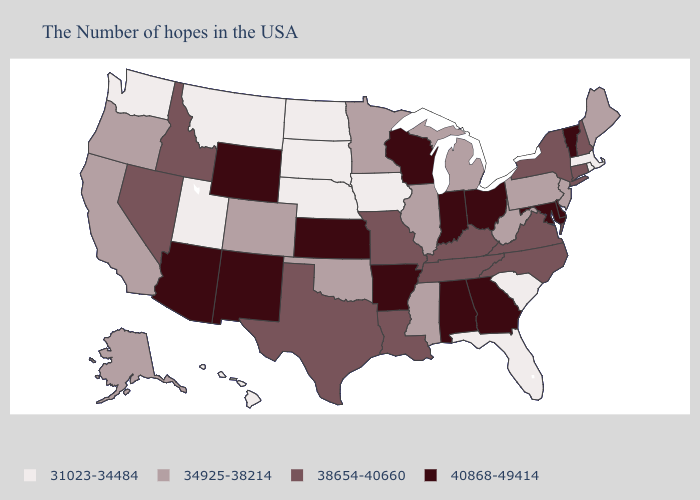Which states have the lowest value in the West?
Write a very short answer. Utah, Montana, Washington, Hawaii. Does Arizona have the same value as Illinois?
Write a very short answer. No. Among the states that border Nevada , does Utah have the highest value?
Be succinct. No. Name the states that have a value in the range 34925-38214?
Be succinct. Maine, New Jersey, Pennsylvania, West Virginia, Michigan, Illinois, Mississippi, Minnesota, Oklahoma, Colorado, California, Oregon, Alaska. Does Wisconsin have a lower value than Missouri?
Give a very brief answer. No. Does Ohio have the highest value in the USA?
Concise answer only. Yes. What is the highest value in the West ?
Keep it brief. 40868-49414. What is the highest value in states that border New Jersey?
Quick response, please. 40868-49414. Name the states that have a value in the range 34925-38214?
Be succinct. Maine, New Jersey, Pennsylvania, West Virginia, Michigan, Illinois, Mississippi, Minnesota, Oklahoma, Colorado, California, Oregon, Alaska. Name the states that have a value in the range 40868-49414?
Concise answer only. Vermont, Delaware, Maryland, Ohio, Georgia, Indiana, Alabama, Wisconsin, Arkansas, Kansas, Wyoming, New Mexico, Arizona. Does Texas have the same value as Idaho?
Quick response, please. Yes. Name the states that have a value in the range 31023-34484?
Quick response, please. Massachusetts, Rhode Island, South Carolina, Florida, Iowa, Nebraska, South Dakota, North Dakota, Utah, Montana, Washington, Hawaii. What is the value of Missouri?
Concise answer only. 38654-40660. What is the value of New Hampshire?
Be succinct. 38654-40660. What is the lowest value in the MidWest?
Quick response, please. 31023-34484. 